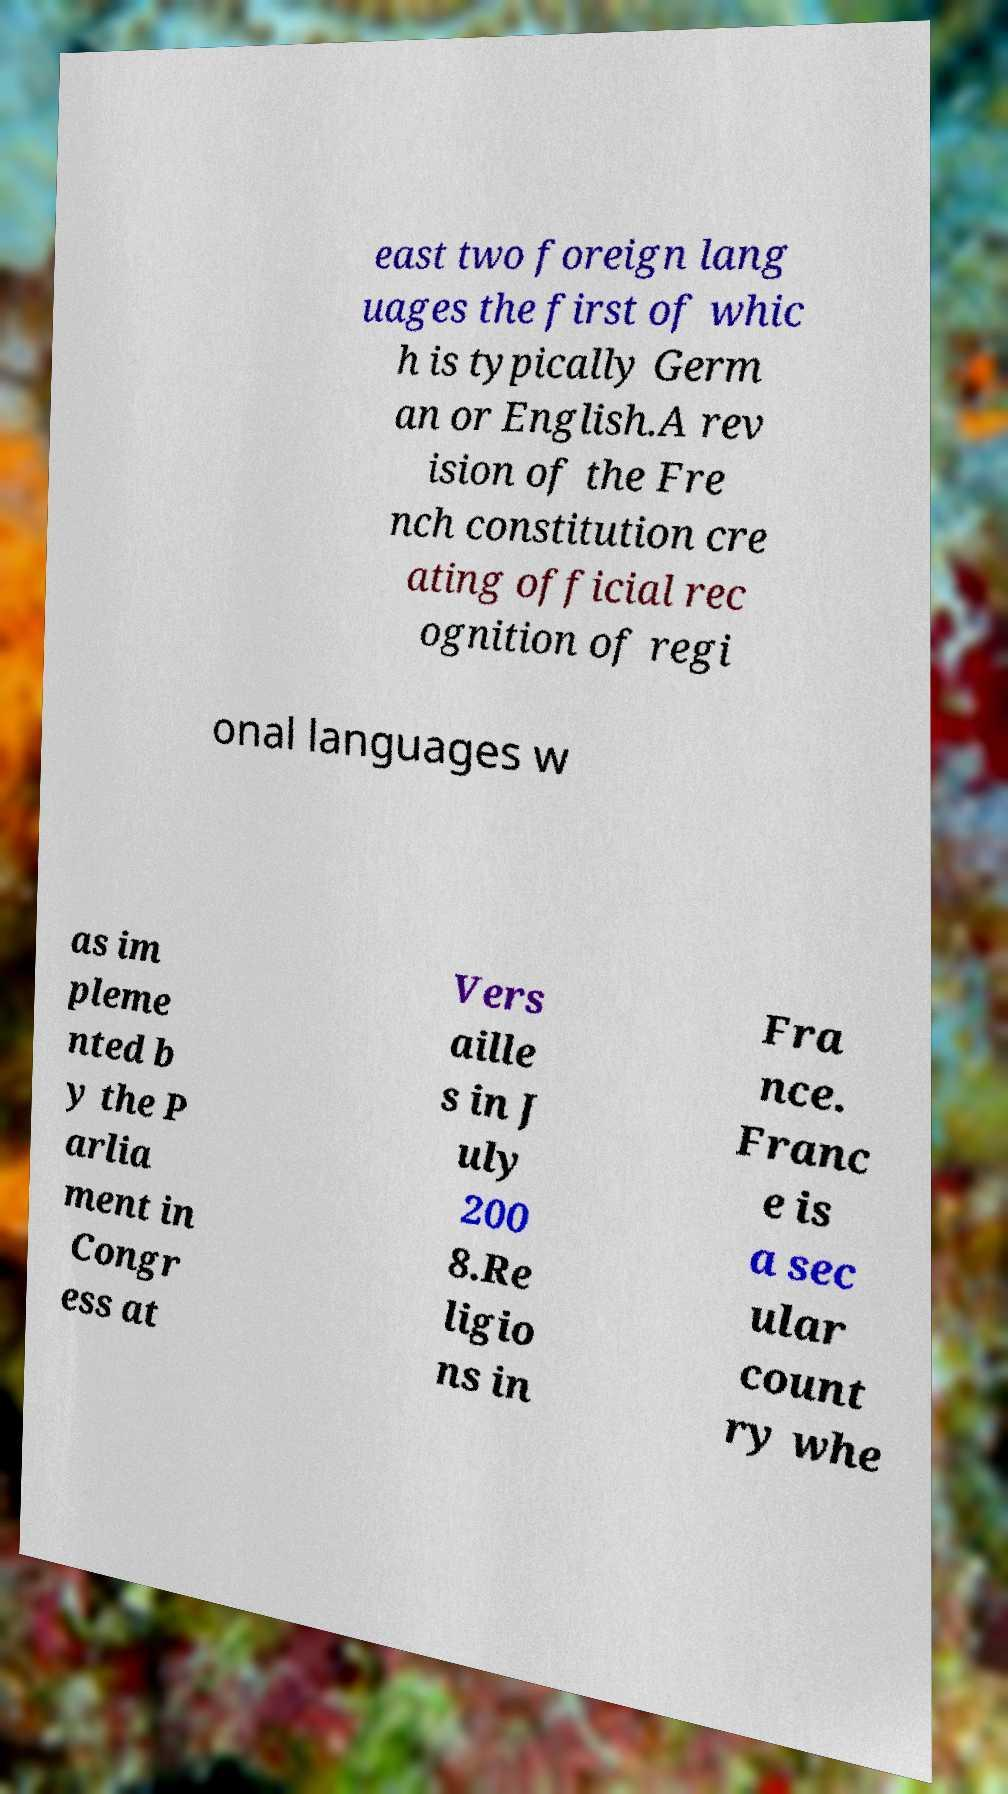Please read and relay the text visible in this image. What does it say? east two foreign lang uages the first of whic h is typically Germ an or English.A rev ision of the Fre nch constitution cre ating official rec ognition of regi onal languages w as im pleme nted b y the P arlia ment in Congr ess at Vers aille s in J uly 200 8.Re ligio ns in Fra nce. Franc e is a sec ular count ry whe 